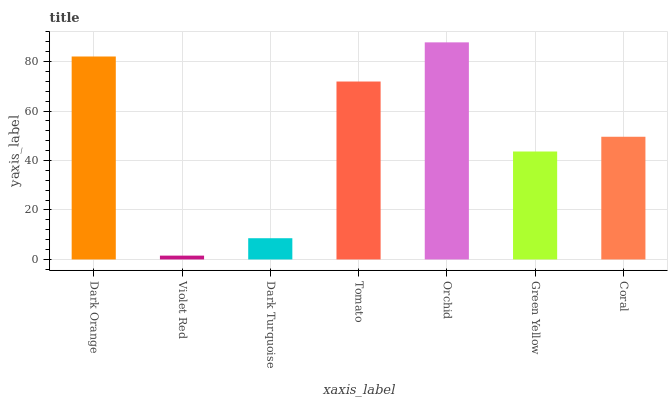Is Violet Red the minimum?
Answer yes or no. Yes. Is Orchid the maximum?
Answer yes or no. Yes. Is Dark Turquoise the minimum?
Answer yes or no. No. Is Dark Turquoise the maximum?
Answer yes or no. No. Is Dark Turquoise greater than Violet Red?
Answer yes or no. Yes. Is Violet Red less than Dark Turquoise?
Answer yes or no. Yes. Is Violet Red greater than Dark Turquoise?
Answer yes or no. No. Is Dark Turquoise less than Violet Red?
Answer yes or no. No. Is Coral the high median?
Answer yes or no. Yes. Is Coral the low median?
Answer yes or no. Yes. Is Dark Orange the high median?
Answer yes or no. No. Is Dark Orange the low median?
Answer yes or no. No. 